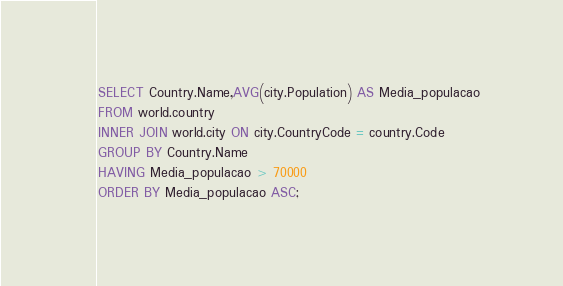Convert code to text. <code><loc_0><loc_0><loc_500><loc_500><_SQL_>SELECT Country.Name,AVG(city.Population) AS Media_populacao
FROM world.country 
INNER JOIN world.city ON city.CountryCode = country.Code
GROUP BY Country.Name
HAVING Media_populacao > 70000
ORDER BY Media_populacao ASC;</code> 